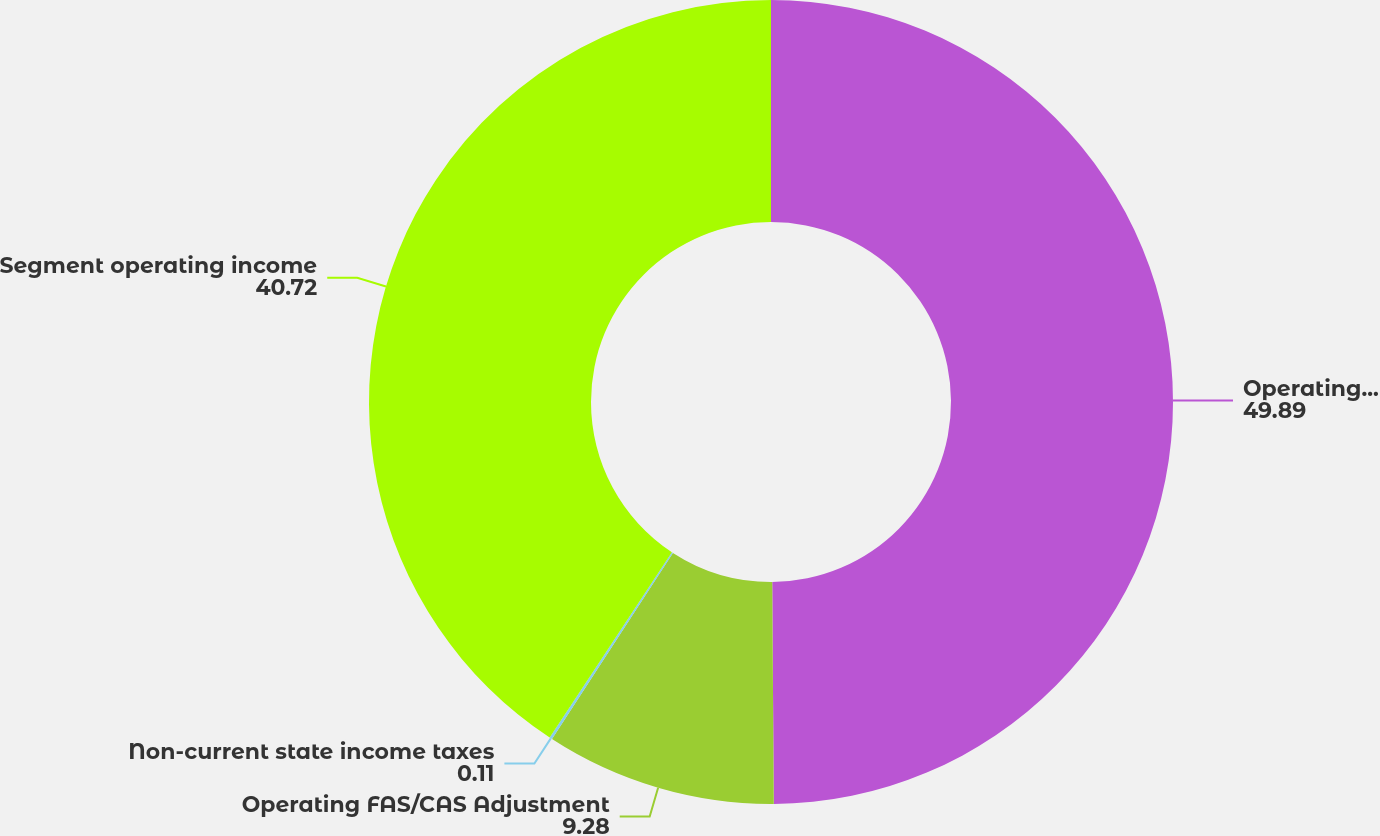<chart> <loc_0><loc_0><loc_500><loc_500><pie_chart><fcel>Operating income<fcel>Operating FAS/CAS Adjustment<fcel>Non-current state income taxes<fcel>Segment operating income<nl><fcel>49.89%<fcel>9.28%<fcel>0.11%<fcel>40.72%<nl></chart> 